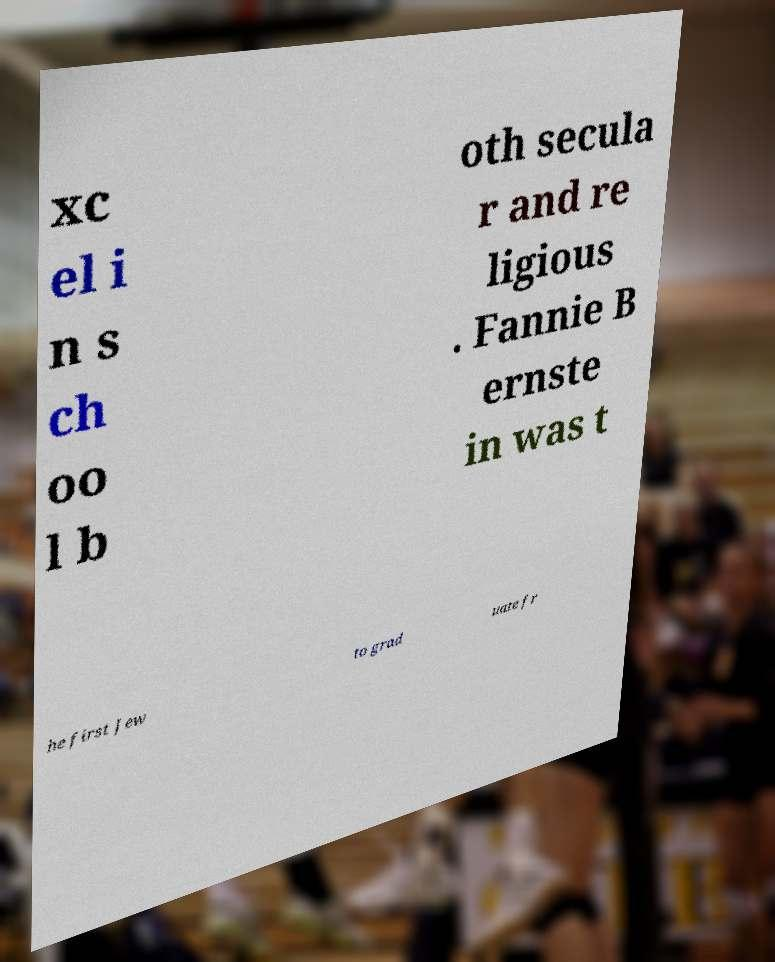Can you read and provide the text displayed in the image?This photo seems to have some interesting text. Can you extract and type it out for me? xc el i n s ch oo l b oth secula r and re ligious . Fannie B ernste in was t he first Jew to grad uate fr 